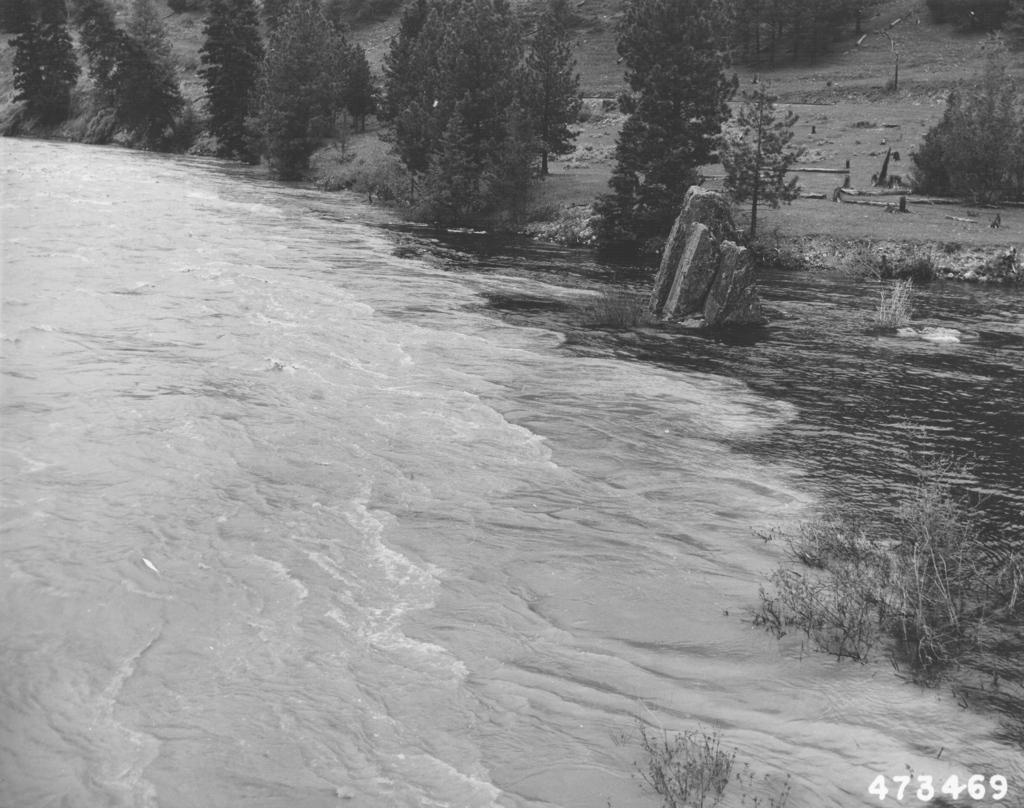How would you summarize this image in a sentence or two? This picture is clicked outside. On the left we can see a water body. On the right we can see the trees, rocks and many other objects. In the bottom right corner we can see the numbers on the image. 